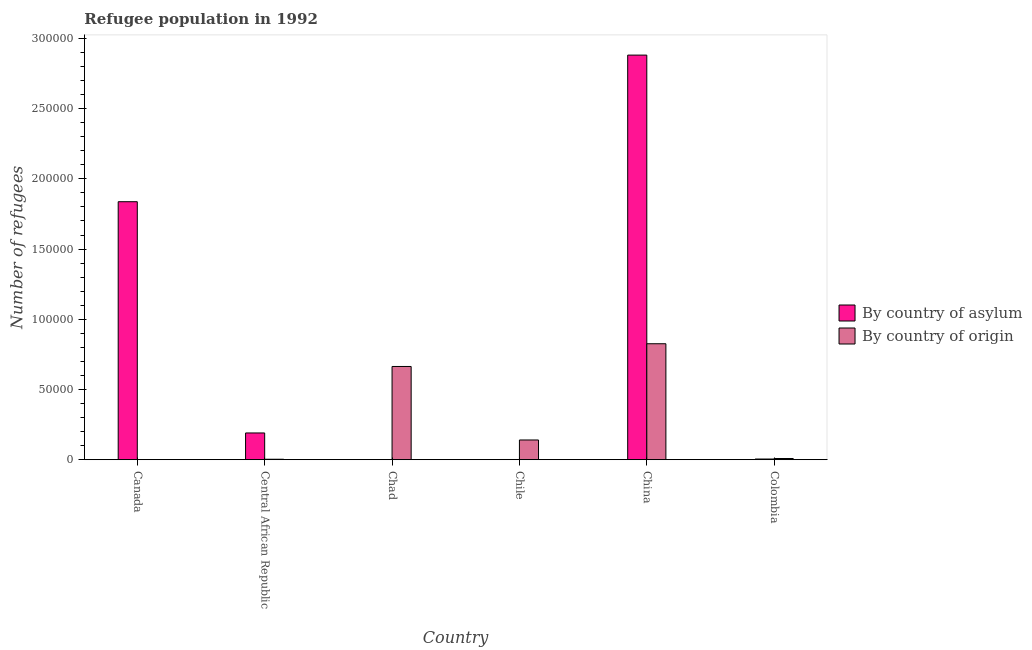How many different coloured bars are there?
Ensure brevity in your answer.  2. Are the number of bars on each tick of the X-axis equal?
Provide a succinct answer. Yes. How many bars are there on the 5th tick from the right?
Your response must be concise. 2. What is the label of the 3rd group of bars from the left?
Make the answer very short. Chad. In how many cases, is the number of bars for a given country not equal to the number of legend labels?
Offer a terse response. 0. What is the number of refugees by country of asylum in Canada?
Your answer should be very brief. 1.84e+05. Across all countries, what is the maximum number of refugees by country of origin?
Your response must be concise. 8.26e+04. Across all countries, what is the minimum number of refugees by country of origin?
Ensure brevity in your answer.  4. In which country was the number of refugees by country of asylum maximum?
Offer a terse response. China. In which country was the number of refugees by country of origin minimum?
Your answer should be compact. Canada. What is the total number of refugees by country of asylum in the graph?
Ensure brevity in your answer.  4.92e+05. What is the difference between the number of refugees by country of asylum in Chad and that in Chile?
Ensure brevity in your answer.  -72. What is the difference between the number of refugees by country of origin in Canada and the number of refugees by country of asylum in Central African Republic?
Your answer should be very brief. -1.90e+04. What is the average number of refugees by country of origin per country?
Your answer should be compact. 2.74e+04. What is the difference between the number of refugees by country of asylum and number of refugees by country of origin in China?
Ensure brevity in your answer.  2.06e+05. What is the ratio of the number of refugees by country of origin in Chile to that in China?
Your answer should be very brief. 0.17. What is the difference between the highest and the second highest number of refugees by country of origin?
Your response must be concise. 1.62e+04. What is the difference between the highest and the lowest number of refugees by country of asylum?
Ensure brevity in your answer.  2.88e+05. What does the 2nd bar from the left in Colombia represents?
Give a very brief answer. By country of origin. What does the 1st bar from the right in Chile represents?
Give a very brief answer. By country of origin. How many bars are there?
Provide a short and direct response. 12. Are all the bars in the graph horizontal?
Make the answer very short. No. What is the difference between two consecutive major ticks on the Y-axis?
Provide a succinct answer. 5.00e+04. Are the values on the major ticks of Y-axis written in scientific E-notation?
Offer a terse response. No. Does the graph contain grids?
Keep it short and to the point. No. Where does the legend appear in the graph?
Provide a short and direct response. Center right. How many legend labels are there?
Your answer should be compact. 2. How are the legend labels stacked?
Give a very brief answer. Vertical. What is the title of the graph?
Offer a very short reply. Refugee population in 1992. Does "Merchandise exports" appear as one of the legend labels in the graph?
Your answer should be very brief. No. What is the label or title of the Y-axis?
Ensure brevity in your answer.  Number of refugees. What is the Number of refugees in By country of asylum in Canada?
Provide a succinct answer. 1.84e+05. What is the Number of refugees in By country of asylum in Central African Republic?
Your answer should be compact. 1.90e+04. What is the Number of refugees in By country of origin in Central African Republic?
Provide a short and direct response. 325. What is the Number of refugees in By country of origin in Chad?
Your answer should be very brief. 6.64e+04. What is the Number of refugees of By country of asylum in Chile?
Offer a very short reply. 142. What is the Number of refugees of By country of origin in Chile?
Offer a very short reply. 1.40e+04. What is the Number of refugees in By country of asylum in China?
Your answer should be compact. 2.88e+05. What is the Number of refugees of By country of origin in China?
Make the answer very short. 8.26e+04. What is the Number of refugees of By country of asylum in Colombia?
Your response must be concise. 478. What is the Number of refugees in By country of origin in Colombia?
Ensure brevity in your answer.  843. Across all countries, what is the maximum Number of refugees in By country of asylum?
Give a very brief answer. 2.88e+05. Across all countries, what is the maximum Number of refugees of By country of origin?
Provide a succinct answer. 8.26e+04. Across all countries, what is the minimum Number of refugees in By country of asylum?
Keep it short and to the point. 70. Across all countries, what is the minimum Number of refugees of By country of origin?
Your answer should be compact. 4. What is the total Number of refugees in By country of asylum in the graph?
Your answer should be very brief. 4.92e+05. What is the total Number of refugees in By country of origin in the graph?
Give a very brief answer. 1.64e+05. What is the difference between the Number of refugees of By country of asylum in Canada and that in Central African Republic?
Your response must be concise. 1.65e+05. What is the difference between the Number of refugees in By country of origin in Canada and that in Central African Republic?
Keep it short and to the point. -321. What is the difference between the Number of refugees of By country of asylum in Canada and that in Chad?
Offer a terse response. 1.84e+05. What is the difference between the Number of refugees in By country of origin in Canada and that in Chad?
Make the answer very short. -6.64e+04. What is the difference between the Number of refugees in By country of asylum in Canada and that in Chile?
Your answer should be very brief. 1.84e+05. What is the difference between the Number of refugees of By country of origin in Canada and that in Chile?
Make the answer very short. -1.40e+04. What is the difference between the Number of refugees in By country of asylum in Canada and that in China?
Provide a short and direct response. -1.04e+05. What is the difference between the Number of refugees of By country of origin in Canada and that in China?
Your answer should be compact. -8.26e+04. What is the difference between the Number of refugees of By country of asylum in Canada and that in Colombia?
Provide a succinct answer. 1.83e+05. What is the difference between the Number of refugees of By country of origin in Canada and that in Colombia?
Offer a terse response. -839. What is the difference between the Number of refugees in By country of asylum in Central African Republic and that in Chad?
Give a very brief answer. 1.90e+04. What is the difference between the Number of refugees in By country of origin in Central African Republic and that in Chad?
Your answer should be very brief. -6.61e+04. What is the difference between the Number of refugees in By country of asylum in Central African Republic and that in Chile?
Make the answer very short. 1.89e+04. What is the difference between the Number of refugees of By country of origin in Central African Republic and that in Chile?
Your answer should be very brief. -1.37e+04. What is the difference between the Number of refugees of By country of asylum in Central African Republic and that in China?
Your response must be concise. -2.69e+05. What is the difference between the Number of refugees of By country of origin in Central African Republic and that in China?
Offer a very short reply. -8.23e+04. What is the difference between the Number of refugees of By country of asylum in Central African Republic and that in Colombia?
Give a very brief answer. 1.86e+04. What is the difference between the Number of refugees of By country of origin in Central African Republic and that in Colombia?
Keep it short and to the point. -518. What is the difference between the Number of refugees in By country of asylum in Chad and that in Chile?
Offer a terse response. -72. What is the difference between the Number of refugees of By country of origin in Chad and that in Chile?
Your answer should be very brief. 5.23e+04. What is the difference between the Number of refugees of By country of asylum in Chad and that in China?
Give a very brief answer. -2.88e+05. What is the difference between the Number of refugees of By country of origin in Chad and that in China?
Offer a terse response. -1.62e+04. What is the difference between the Number of refugees of By country of asylum in Chad and that in Colombia?
Give a very brief answer. -408. What is the difference between the Number of refugees of By country of origin in Chad and that in Colombia?
Make the answer very short. 6.55e+04. What is the difference between the Number of refugees of By country of asylum in Chile and that in China?
Your answer should be very brief. -2.88e+05. What is the difference between the Number of refugees of By country of origin in Chile and that in China?
Keep it short and to the point. -6.85e+04. What is the difference between the Number of refugees of By country of asylum in Chile and that in Colombia?
Offer a very short reply. -336. What is the difference between the Number of refugees of By country of origin in Chile and that in Colombia?
Ensure brevity in your answer.  1.32e+04. What is the difference between the Number of refugees in By country of asylum in China and that in Colombia?
Your response must be concise. 2.88e+05. What is the difference between the Number of refugees of By country of origin in China and that in Colombia?
Your response must be concise. 8.17e+04. What is the difference between the Number of refugees in By country of asylum in Canada and the Number of refugees in By country of origin in Central African Republic?
Give a very brief answer. 1.83e+05. What is the difference between the Number of refugees of By country of asylum in Canada and the Number of refugees of By country of origin in Chad?
Your answer should be very brief. 1.17e+05. What is the difference between the Number of refugees of By country of asylum in Canada and the Number of refugees of By country of origin in Chile?
Give a very brief answer. 1.70e+05. What is the difference between the Number of refugees of By country of asylum in Canada and the Number of refugees of By country of origin in China?
Your answer should be compact. 1.01e+05. What is the difference between the Number of refugees in By country of asylum in Canada and the Number of refugees in By country of origin in Colombia?
Give a very brief answer. 1.83e+05. What is the difference between the Number of refugees in By country of asylum in Central African Republic and the Number of refugees in By country of origin in Chad?
Ensure brevity in your answer.  -4.73e+04. What is the difference between the Number of refugees in By country of asylum in Central African Republic and the Number of refugees in By country of origin in Chile?
Offer a terse response. 4997. What is the difference between the Number of refugees of By country of asylum in Central African Republic and the Number of refugees of By country of origin in China?
Make the answer very short. -6.35e+04. What is the difference between the Number of refugees in By country of asylum in Central African Republic and the Number of refugees in By country of origin in Colombia?
Your answer should be compact. 1.82e+04. What is the difference between the Number of refugees in By country of asylum in Chad and the Number of refugees in By country of origin in Chile?
Keep it short and to the point. -1.40e+04. What is the difference between the Number of refugees of By country of asylum in Chad and the Number of refugees of By country of origin in China?
Give a very brief answer. -8.25e+04. What is the difference between the Number of refugees of By country of asylum in Chad and the Number of refugees of By country of origin in Colombia?
Ensure brevity in your answer.  -773. What is the difference between the Number of refugees of By country of asylum in Chile and the Number of refugees of By country of origin in China?
Offer a terse response. -8.24e+04. What is the difference between the Number of refugees of By country of asylum in Chile and the Number of refugees of By country of origin in Colombia?
Keep it short and to the point. -701. What is the difference between the Number of refugees of By country of asylum in China and the Number of refugees of By country of origin in Colombia?
Your response must be concise. 2.87e+05. What is the average Number of refugees of By country of asylum per country?
Provide a short and direct response. 8.19e+04. What is the average Number of refugees of By country of origin per country?
Keep it short and to the point. 2.74e+04. What is the difference between the Number of refugees in By country of asylum and Number of refugees in By country of origin in Canada?
Make the answer very short. 1.84e+05. What is the difference between the Number of refugees in By country of asylum and Number of refugees in By country of origin in Central African Republic?
Offer a very short reply. 1.87e+04. What is the difference between the Number of refugees in By country of asylum and Number of refugees in By country of origin in Chad?
Your answer should be very brief. -6.63e+04. What is the difference between the Number of refugees of By country of asylum and Number of refugees of By country of origin in Chile?
Your response must be concise. -1.39e+04. What is the difference between the Number of refugees in By country of asylum and Number of refugees in By country of origin in China?
Your answer should be very brief. 2.06e+05. What is the difference between the Number of refugees in By country of asylum and Number of refugees in By country of origin in Colombia?
Your answer should be compact. -365. What is the ratio of the Number of refugees in By country of asylum in Canada to that in Central African Republic?
Provide a succinct answer. 9.65. What is the ratio of the Number of refugees in By country of origin in Canada to that in Central African Republic?
Your answer should be compact. 0.01. What is the ratio of the Number of refugees of By country of asylum in Canada to that in Chad?
Offer a very short reply. 2624.61. What is the ratio of the Number of refugees of By country of asylum in Canada to that in Chile?
Give a very brief answer. 1293.82. What is the ratio of the Number of refugees in By country of asylum in Canada to that in China?
Your response must be concise. 0.64. What is the ratio of the Number of refugees in By country of origin in Canada to that in China?
Your response must be concise. 0. What is the ratio of the Number of refugees of By country of asylum in Canada to that in Colombia?
Offer a terse response. 384.36. What is the ratio of the Number of refugees in By country of origin in Canada to that in Colombia?
Ensure brevity in your answer.  0. What is the ratio of the Number of refugees in By country of asylum in Central African Republic to that in Chad?
Offer a very short reply. 272. What is the ratio of the Number of refugees of By country of origin in Central African Republic to that in Chad?
Make the answer very short. 0. What is the ratio of the Number of refugees of By country of asylum in Central African Republic to that in Chile?
Keep it short and to the point. 134.08. What is the ratio of the Number of refugees of By country of origin in Central African Republic to that in Chile?
Offer a very short reply. 0.02. What is the ratio of the Number of refugees of By country of asylum in Central African Republic to that in China?
Provide a succinct answer. 0.07. What is the ratio of the Number of refugees in By country of origin in Central African Republic to that in China?
Your answer should be compact. 0. What is the ratio of the Number of refugees of By country of asylum in Central African Republic to that in Colombia?
Provide a short and direct response. 39.83. What is the ratio of the Number of refugees of By country of origin in Central African Republic to that in Colombia?
Provide a short and direct response. 0.39. What is the ratio of the Number of refugees in By country of asylum in Chad to that in Chile?
Your response must be concise. 0.49. What is the ratio of the Number of refugees in By country of origin in Chad to that in Chile?
Offer a terse response. 4.73. What is the ratio of the Number of refugees of By country of origin in Chad to that in China?
Give a very brief answer. 0.8. What is the ratio of the Number of refugees of By country of asylum in Chad to that in Colombia?
Offer a terse response. 0.15. What is the ratio of the Number of refugees in By country of origin in Chad to that in Colombia?
Your answer should be very brief. 78.74. What is the ratio of the Number of refugees in By country of asylum in Chile to that in China?
Provide a short and direct response. 0. What is the ratio of the Number of refugees of By country of origin in Chile to that in China?
Your answer should be compact. 0.17. What is the ratio of the Number of refugees in By country of asylum in Chile to that in Colombia?
Your answer should be very brief. 0.3. What is the ratio of the Number of refugees of By country of origin in Chile to that in Colombia?
Keep it short and to the point. 16.66. What is the ratio of the Number of refugees of By country of asylum in China to that in Colombia?
Your response must be concise. 602.77. What is the ratio of the Number of refugees of By country of origin in China to that in Colombia?
Your response must be concise. 97.95. What is the difference between the highest and the second highest Number of refugees in By country of asylum?
Provide a succinct answer. 1.04e+05. What is the difference between the highest and the second highest Number of refugees in By country of origin?
Provide a succinct answer. 1.62e+04. What is the difference between the highest and the lowest Number of refugees in By country of asylum?
Keep it short and to the point. 2.88e+05. What is the difference between the highest and the lowest Number of refugees in By country of origin?
Give a very brief answer. 8.26e+04. 